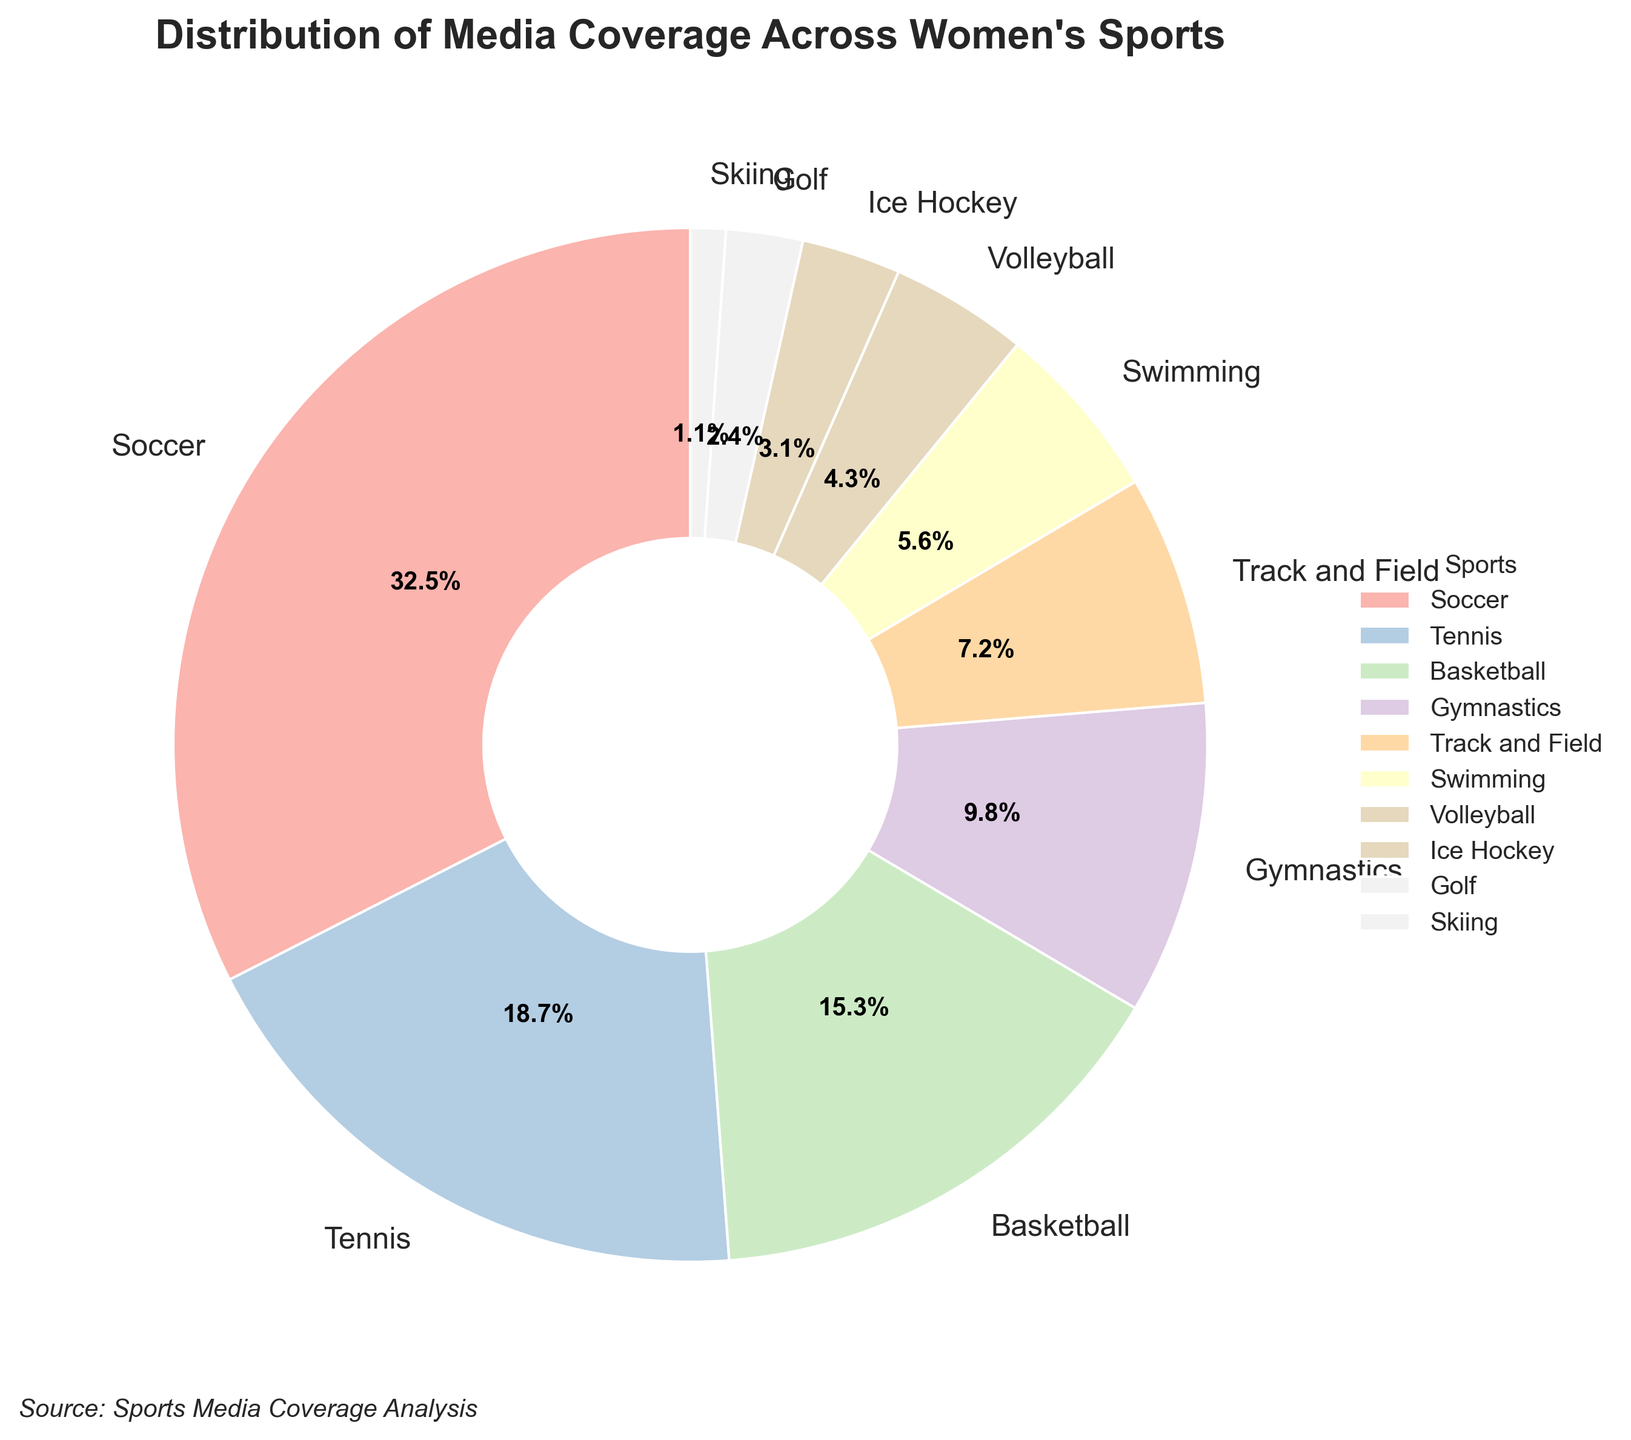What's the highest percentage of media coverage? The highest percentage of media coverage is the largest section of the pie chart. Soccer has the largest slice, marked as 32.5%.
Answer: 32.5% Which sports collectively receive more than 50% of the media coverage? To find out which sports collectively receive more than 50% of the coverage, sum the percentages of the largest categories until the total exceeds 50%. Soccer (32.5%) and Tennis (18.7%) add up to 32.5% + 18.7% = 51.2%, which is more than 50%.
Answer: Soccer and Tennis Which sport has the second least media coverage? The second least coverage can be identified by looking for the second smallest slice of the pie. Golf has a higher percentage (2.4%) than Skiing but lower than any other sport.
Answer: Golf How much more coverage does Soccer get than Gymnastics? To find out how much more coverage Soccer gets than Gymnastics, subtract the percentage for Gymnastics from that for Soccer: 32.5% - 9.8% = 22.7%.
Answer: 22.7% What is the combined media coverage percentage for Volleyball and Ice Hockey? Add the percentages for Volleyball and Ice Hockey: 4.3% + 3.1% = 7.4%.
Answer: 7.4% Which sport has a coverage percentage closest to 10% without exceeding it? Look for the sport with the closest percentage value to 10% without exceeding it. Gymnastics has a percentage of 9.8%, which is closest.
Answer: Gymnastics What is the difference in media coverage between the highest and lowest covered sports? Subtract the percentage of the least covered sport (Skiing, 1.1%) from the most covered sport (Soccer, 32.5%): 32.5% - 1.1% = 31.4%.
Answer: 31.4% Among Track and Field, Swimming, and Volleyball, which sport gets the least coverage? Compare the percentages of Track and Field (7.2%), Swimming (5.6%), and Volleyball (4.3%). Volleyball has the smallest percentage.
Answer: Volleyball By how much does the coverage of Basketball exceed that of Ice Hockey? Subtract the percentage for Ice Hockey from that for Basketball: 15.3% - 3.1% = 12.2%.
Answer: 12.2% What is the proportion of media coverage for Soccer compared to Tennis? Divide the percentage of Soccer by that of Tennis to find the proportion: 32.5% / 18.7% ≈ 1.74.
Answer: 1.74 